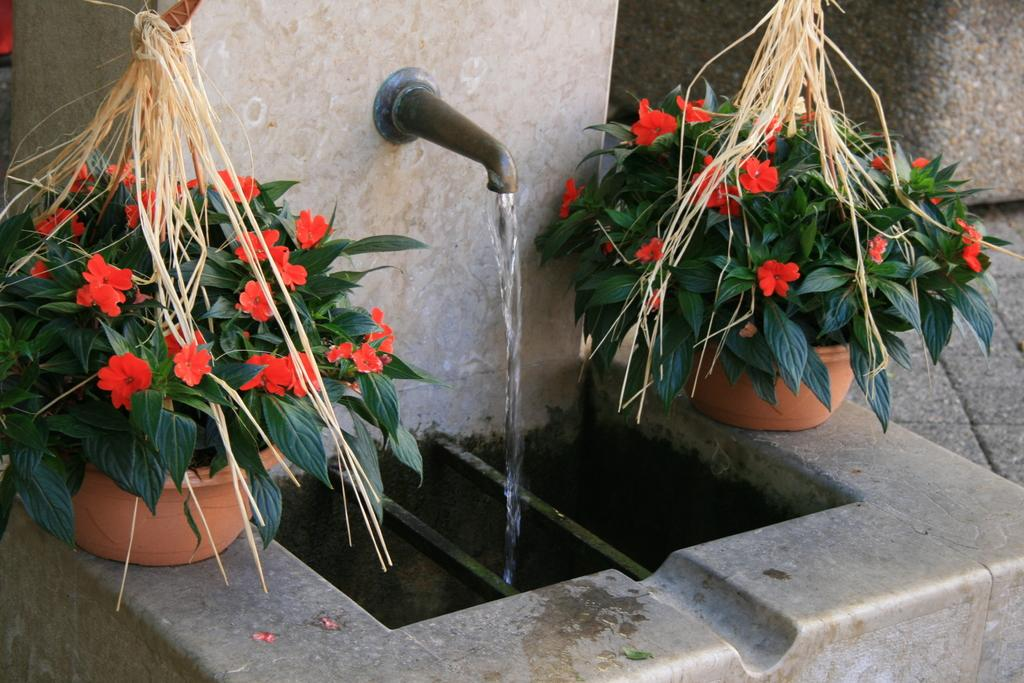How many flower pots with plants are in the image? There are two flower pots with plants in the image. What is special about the plants in the flower pots? The plants have flowers. What color are some of the flowers? Some of the flowers are red in color. What is the source of water in the image? There is a tap in the image, and water is flowing from it. What type of music is being played in the background of the image? There is no music playing in the background of the image. 